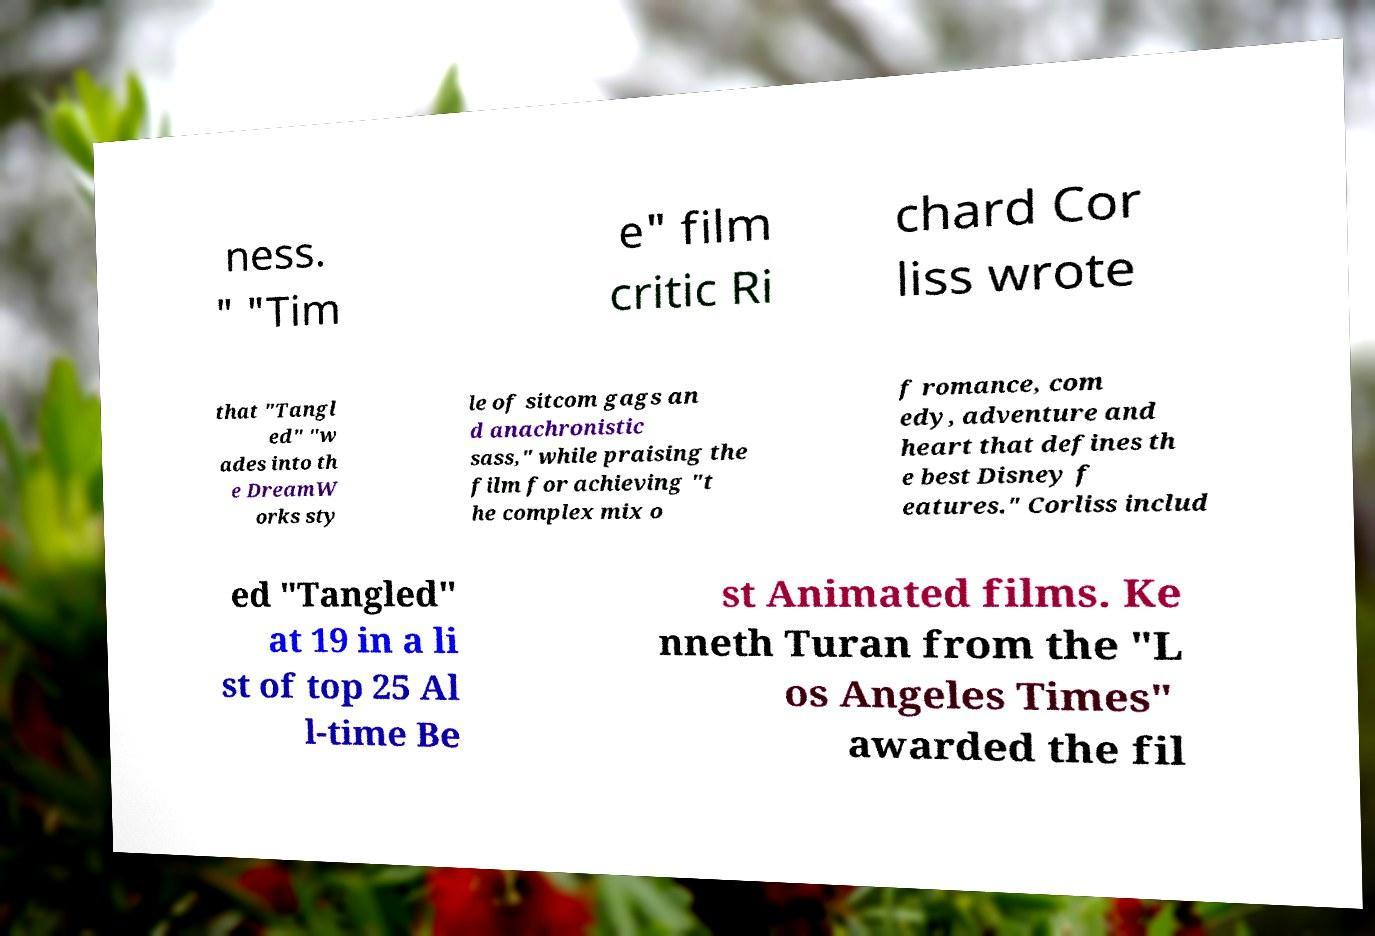Please read and relay the text visible in this image. What does it say? ness. " "Tim e" film critic Ri chard Cor liss wrote that "Tangl ed" "w ades into th e DreamW orks sty le of sitcom gags an d anachronistic sass," while praising the film for achieving "t he complex mix o f romance, com edy, adventure and heart that defines th e best Disney f eatures." Corliss includ ed "Tangled" at 19 in a li st of top 25 Al l-time Be st Animated films. Ke nneth Turan from the "L os Angeles Times" awarded the fil 